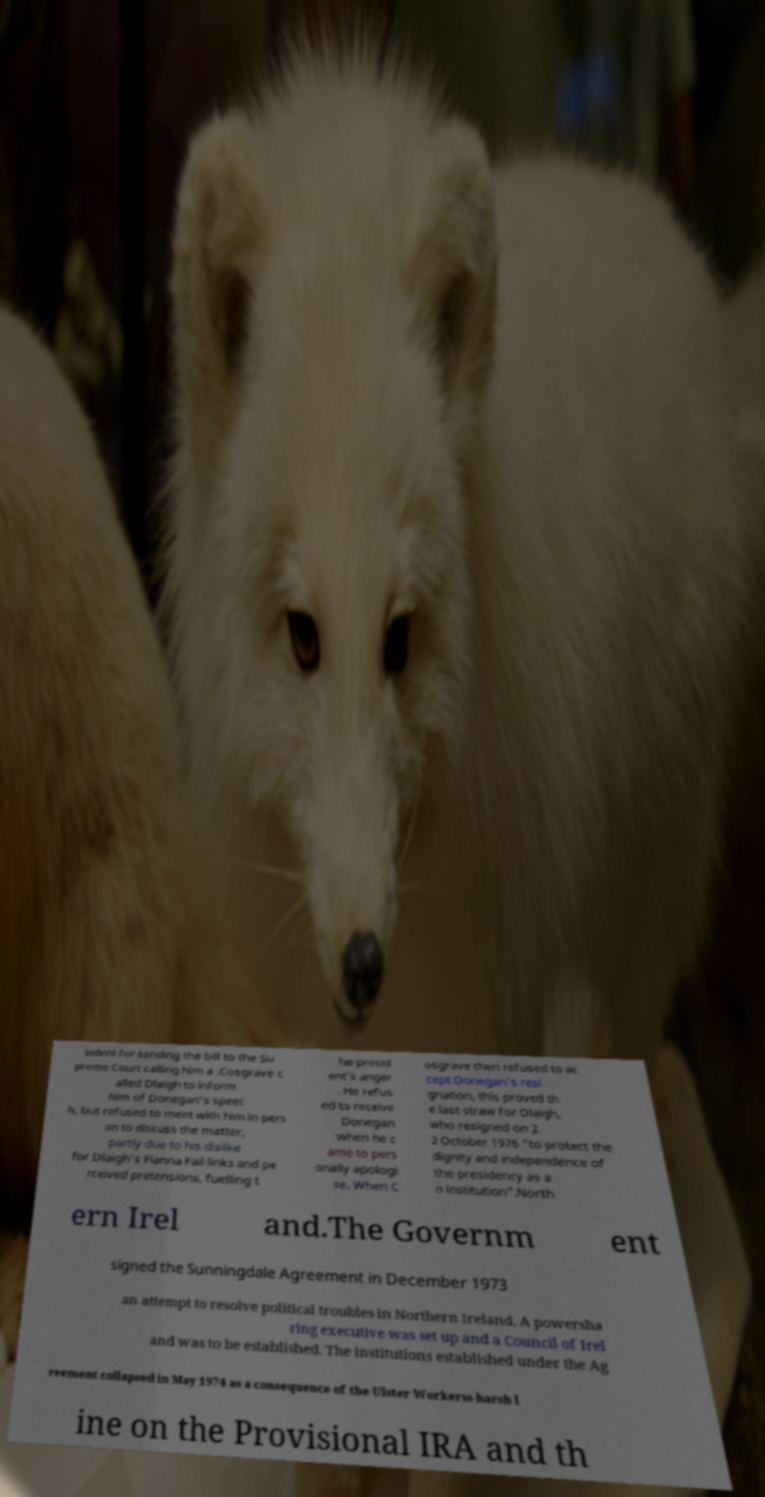What messages or text are displayed in this image? I need them in a readable, typed format. sident for sending the bill to the Su preme Court calling him a .Cosgrave c alled Dlaigh to inform him of Donegan's speec h, but refused to meet with him in pers on to discuss the matter, partly due to his dislike for Dlaigh's Fianna Fail links and pe rceived pretensions, fuelling t he presid ent's anger . He refus ed to receive Donegan when he c ame to pers onally apologi se. When C osgrave then refused to ac cept Donegan's resi gnation, this proved th e last straw for Dlaigh, who resigned on 2 2 October 1976 "to protect the dignity and independence of the presidency as a n institution".North ern Irel and.The Governm ent signed the Sunningdale Agreement in December 1973 an attempt to resolve political troubles in Northern Ireland. A powersha ring executive was set up and a Council of Irel and was to be established. The institutions established under the Ag reement collapsed in May 1974 as a consequence of the Ulster Workerss harsh l ine on the Provisional IRA and th 